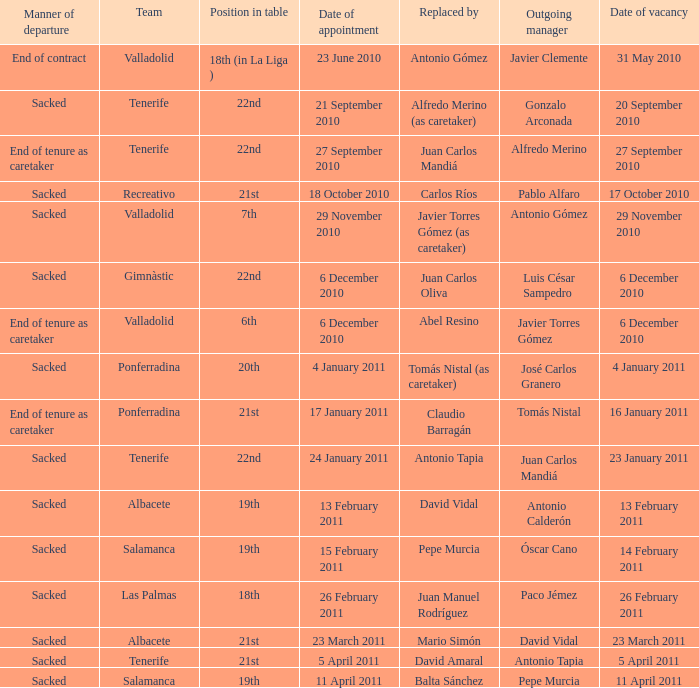What was the position of appointment date 17 january 2011 21st. 